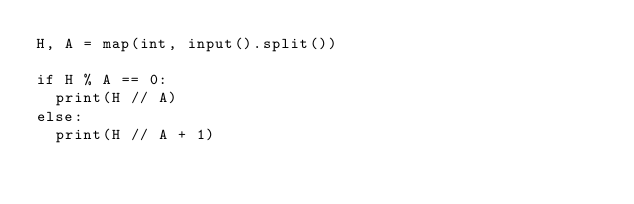Convert code to text. <code><loc_0><loc_0><loc_500><loc_500><_Python_>H, A = map(int, input().split())

if H % A == 0:
	print(H // A)
else:
	print(H // A + 1)
</code> 